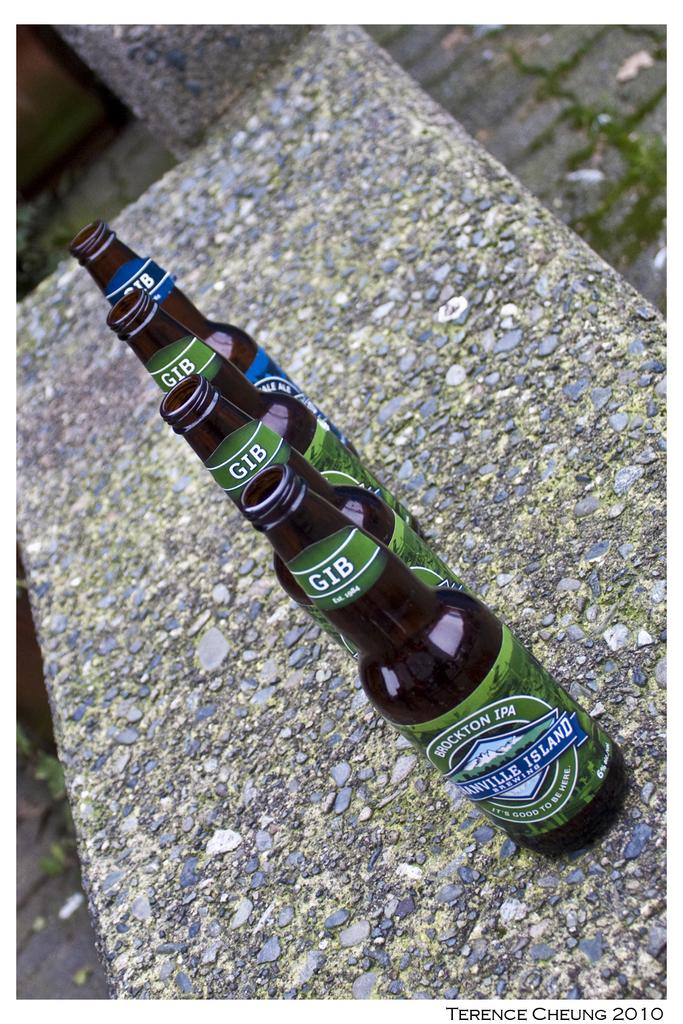What is the 3 letters in the neck of these bottles?
Offer a very short reply. Gib. 